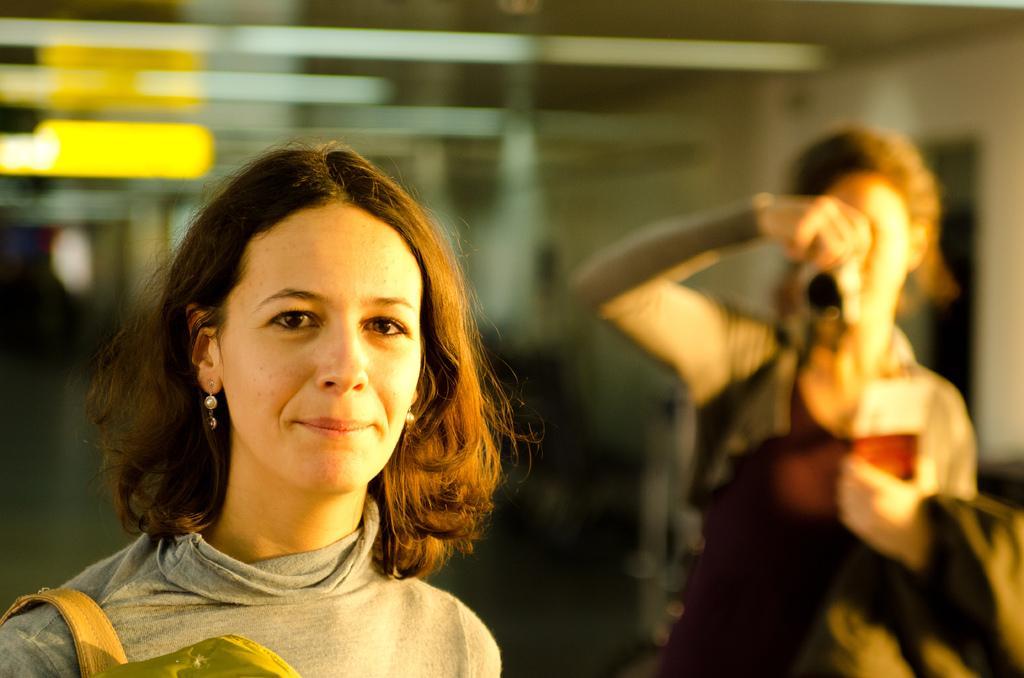Describe this image in one or two sentences. In this image we can see two women standing and holding some objects. The background is blurred and right side of the image one woman taking a photo with the camera. 